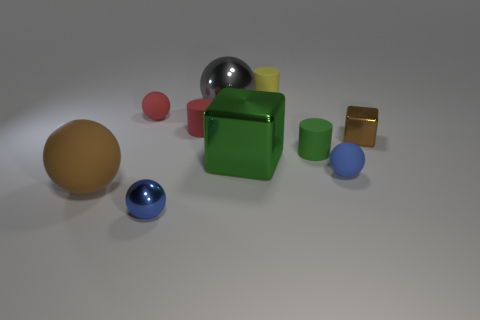Subtract all blue matte spheres. How many spheres are left? 4 Subtract all purple cylinders. How many blue balls are left? 2 Subtract all green cylinders. How many cylinders are left? 2 Subtract all blocks. How many objects are left? 8 Add 7 yellow matte cylinders. How many yellow matte cylinders exist? 8 Subtract 0 red cubes. How many objects are left? 10 Subtract 1 balls. How many balls are left? 4 Subtract all purple cylinders. Subtract all cyan balls. How many cylinders are left? 3 Subtract all tiny matte blocks. Subtract all large green shiny things. How many objects are left? 9 Add 1 spheres. How many spheres are left? 6 